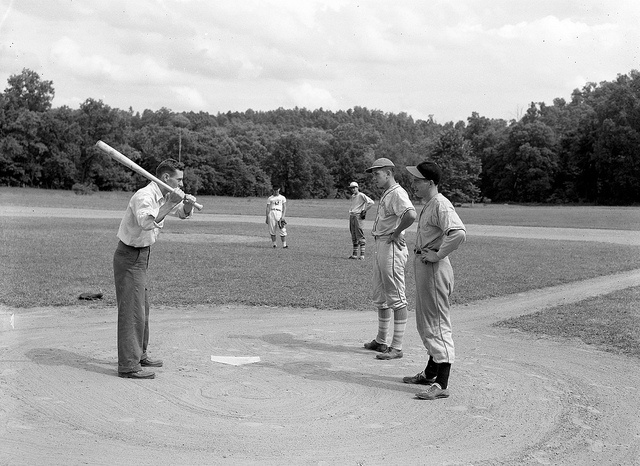Describe the objects in this image and their specific colors. I can see people in white, gray, darkgray, black, and lightgray tones, people in white, gray, darkgray, black, and lightgray tones, people in white, gray, darkgray, lightgray, and black tones, people in white, darkgray, gray, black, and lightgray tones, and people in white, darkgray, lightgray, gray, and black tones in this image. 